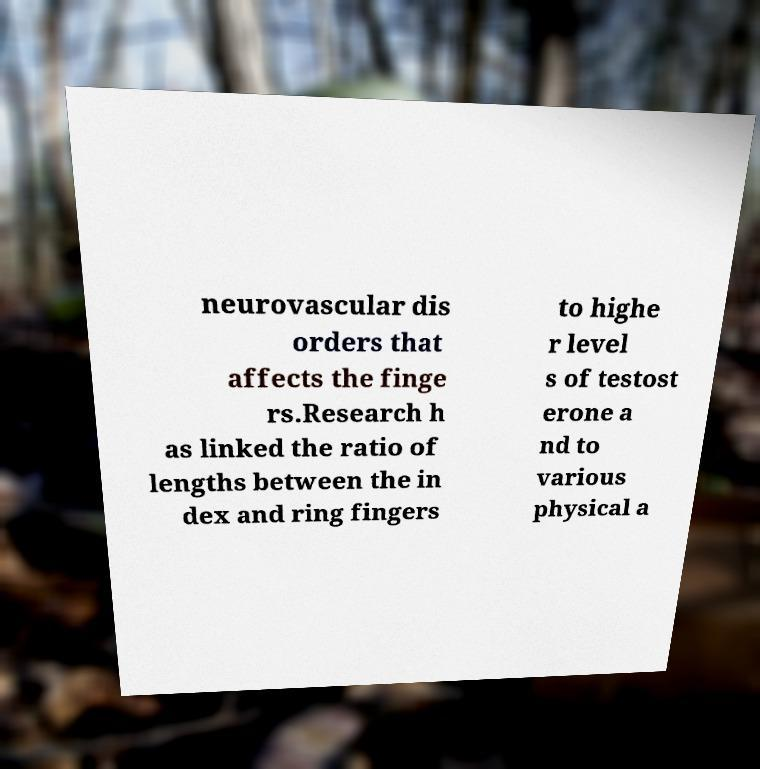Could you assist in decoding the text presented in this image and type it out clearly? neurovascular dis orders that affects the finge rs.Research h as linked the ratio of lengths between the in dex and ring fingers to highe r level s of testost erone a nd to various physical a 